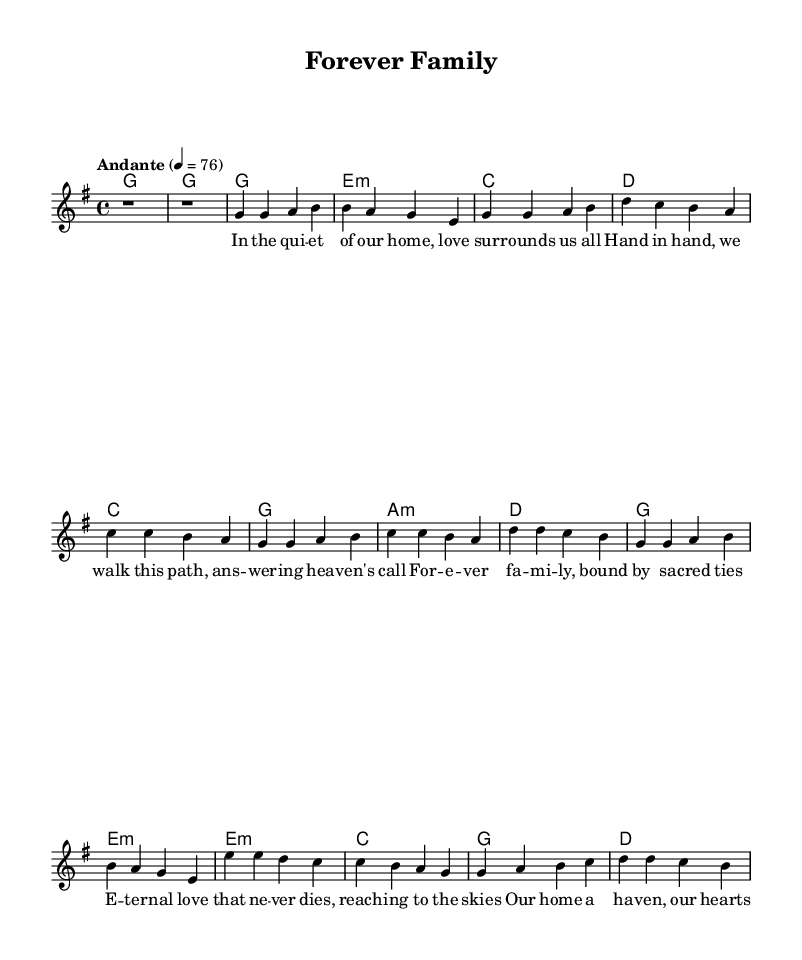What is the key signature of this music? The key signature is identified by the set of sharps or flats placed on the staff at the beginning of the piece. In this case, the music is in G major, which has one sharp (F#).
Answer: G major What is the time signature of the piece? The time signature appears at the beginning of the music, indicating how many beats are in each measure. This piece shows 4/4 time, which means there are four beats per measure and a quarter note receives one beat.
Answer: 4/4 What is the tempo marking of this piece? The tempo marking defines the speed of the music. In this sheet, the tempo is indicated as "Andante" with a metronome marking of 76 beats per minute, suggesting a moderately slow pace.
Answer: Andante, 76 How many verses are present in the music? The music includes two verses—Verse 1 is fully specified, and Verse 2 is noted to be abbreviated. The separate section for verses helps in identifying the structure.
Answer: 2 verses What is the main theme depicted in the chorus lyrics? The chorus emphasizes the theme of family and eternal love. It highlights sacred connections, which reflects strong family values and lasting bonds, characteristic of soft rock ballads.
Answer: Family and eternal love In which section does the bridge occur? The bridge is a distinct section often found after the verses and before the final chorus. In this piece, the bridge follows the second verse and serves to connect the themes between the verse and chorus, indicating a shift in the lyrical narrative.
Answer: After Verse 2 What musical techniques are present in the harmonies? The harmonies utilize a basic chord structure that supports the melody. The chords include G major, E minor, C major, and D major, common in rock and ballad music, providing a harmonic foundation that enhances the emotional impact of the lyrics.
Answer: Chord progression 